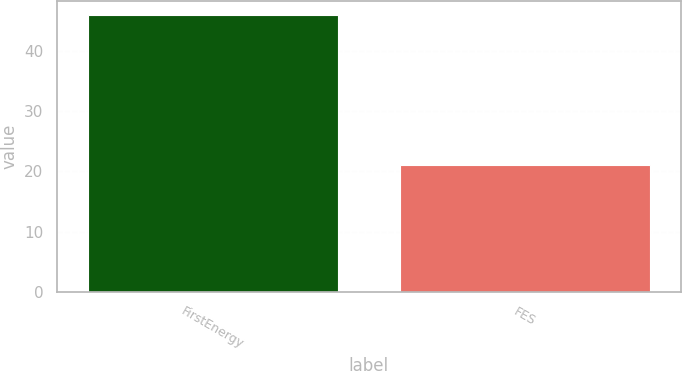<chart> <loc_0><loc_0><loc_500><loc_500><bar_chart><fcel>FirstEnergy<fcel>FES<nl><fcel>46<fcel>21<nl></chart> 